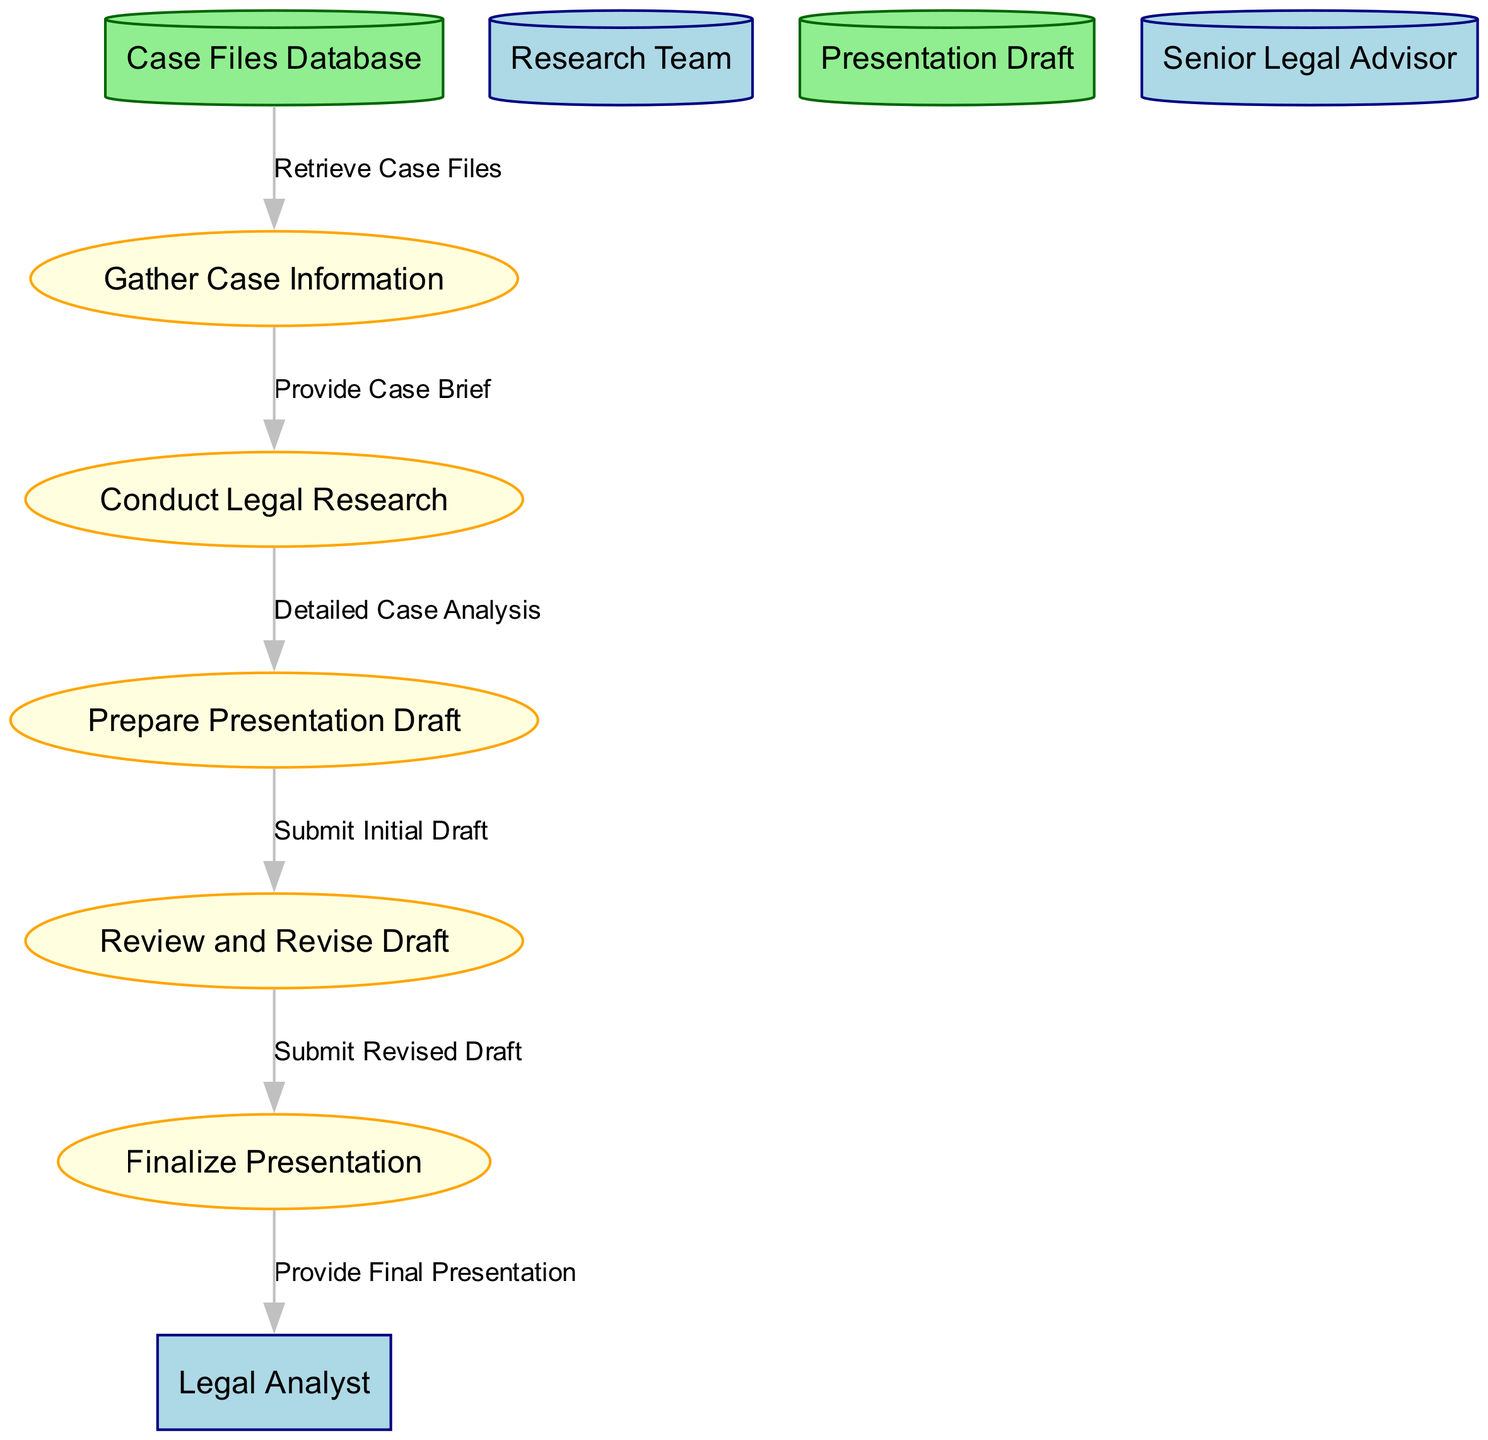What is the first process in the diagram? The first process in the diagram is titled "Gather Case Information." This is identified as the initial step that takes input from the case files database, leading to the compilation of a case brief.
Answer: Gather Case Information Who reviews the initial presentation draft? The initial presentation draft is reviewed by the "Senior Legal Advisor." This is indicated in the "Review and Revise Draft" process where the senior legal advisor's participation is specified.
Answer: Senior Legal Advisor How many external entities are represented in the diagram? The diagram shows three external entities: "Legal Analyst," "Research Team," and "Senior Legal Advisor." Counting these provides us with the total number of external entities in the diagram.
Answer: 3 What is the final output of the process? The final output of the process is the "Final Case Presentation." This is the last element produced from the "Finalize Presentation" process.
Answer: Final Case Presentation What data flows from "Prepare Presentation Draft" to "Review and Revise Draft"? The data flowing from "Prepare Presentation Draft" to "Review and Revise Draft" is labeled "Submit Initial Draft." This shows the specific data transfer occurring at this point in the flow.
Answer: Submit Initial Draft What is the role of the Research Team in the process? The Research Team collaborates with the Legal Analyst to conduct legal research. Their role is to assist in generating the "Detailed Case Analysis" from the "Case Brief."
Answer: Conduct Legal Research Which data store is used to retrieve case files? The data store used to retrieve case files is the "Case Files Database." It serves as the initial source of information needed for the legal analysis process.
Answer: Case Files Database What information is provided by the "Conduct Legal Research"? The "Conduct Legal Research" process provides the output known as "Detailed Case Analysis," which is essential for preparing the presentation draft.
Answer: Detailed Case Analysis 